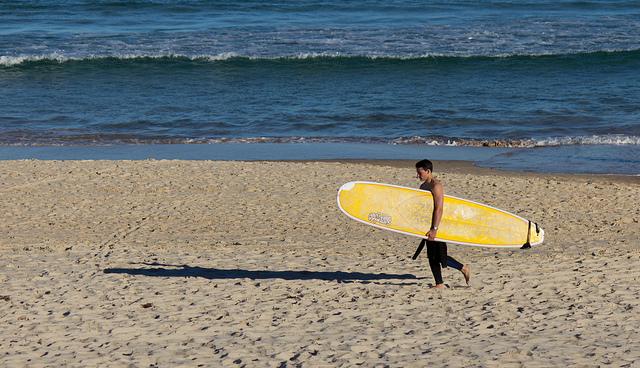What is this man holding?
Short answer required. Surfboard. Is there more than one person in this photo?
Be succinct. No. What is the man walking on?
Short answer required. Sand. 